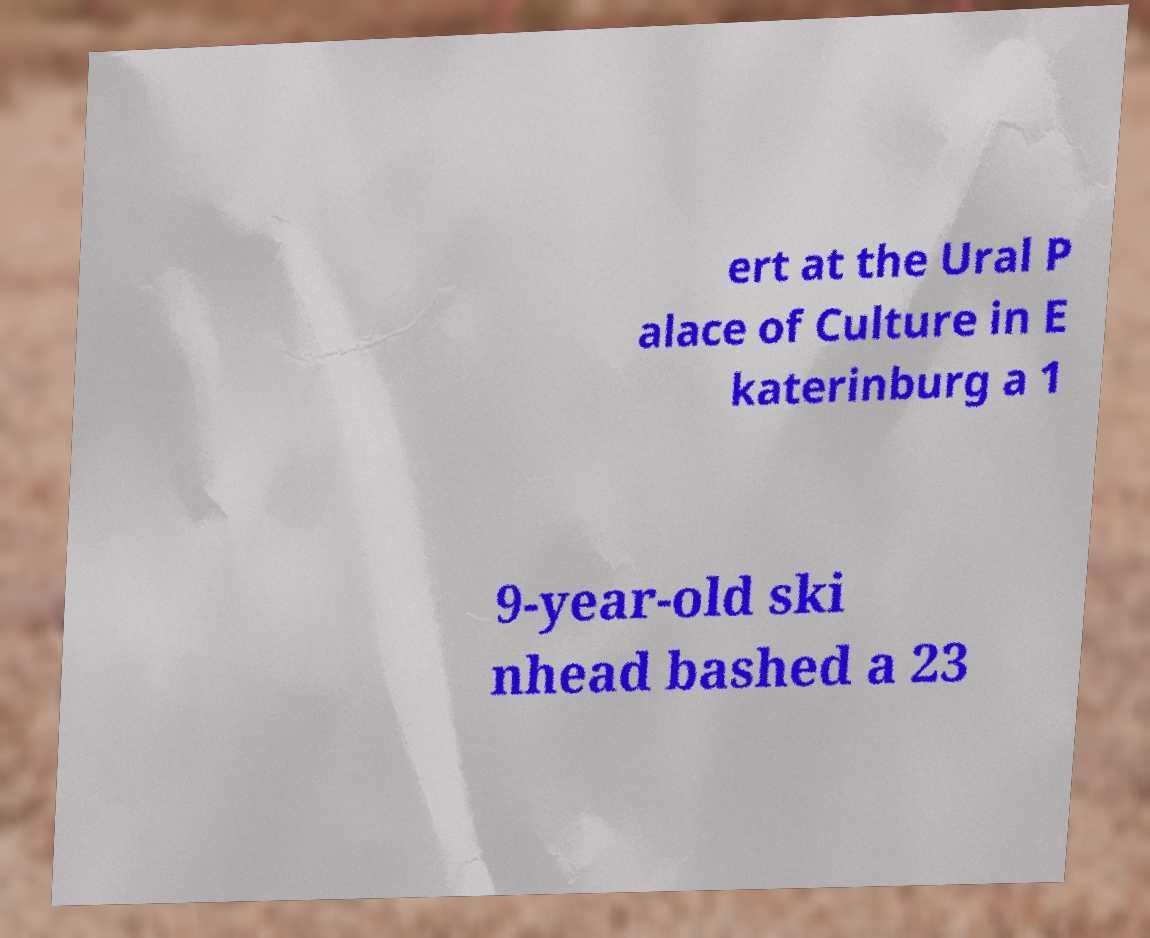Could you assist in decoding the text presented in this image and type it out clearly? ert at the Ural P alace of Culture in E katerinburg a 1 9-year-old ski nhead bashed a 23 